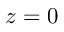Convert formula to latex. <formula><loc_0><loc_0><loc_500><loc_500>z = 0</formula> 